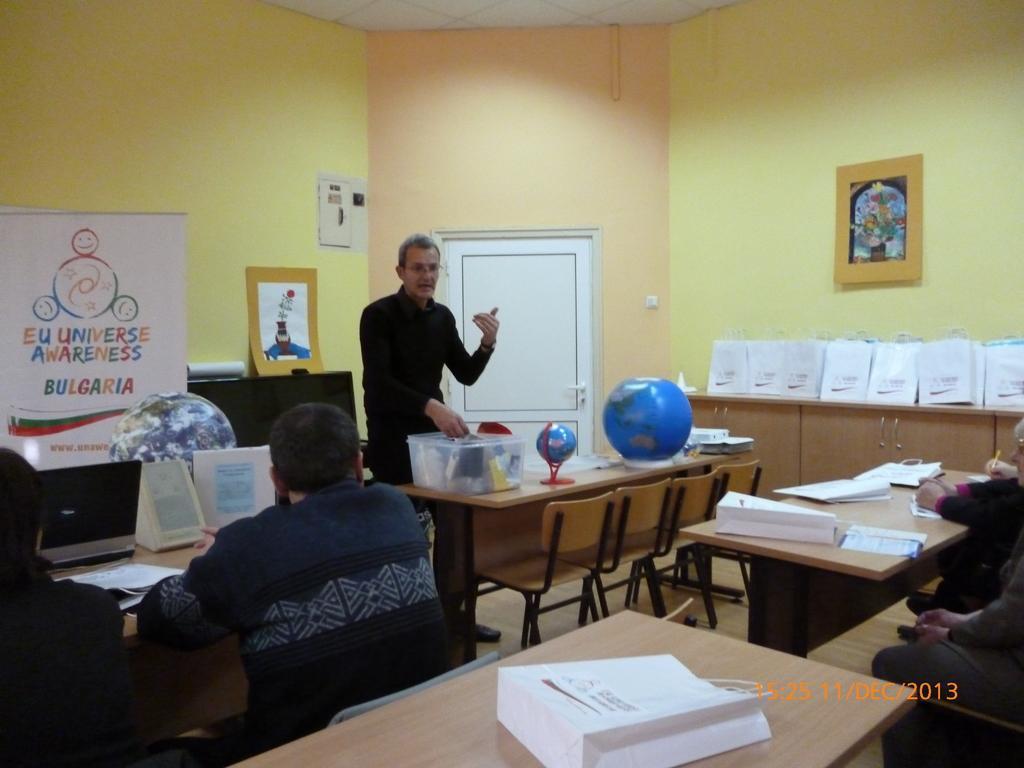Describe this image in one or two sentences. In this image i can see a man standing there is a box a globe, on a table there are few chairs at the back ground i can see a banner, a cup board, a man sitting on a chair frame attached to a wall. 